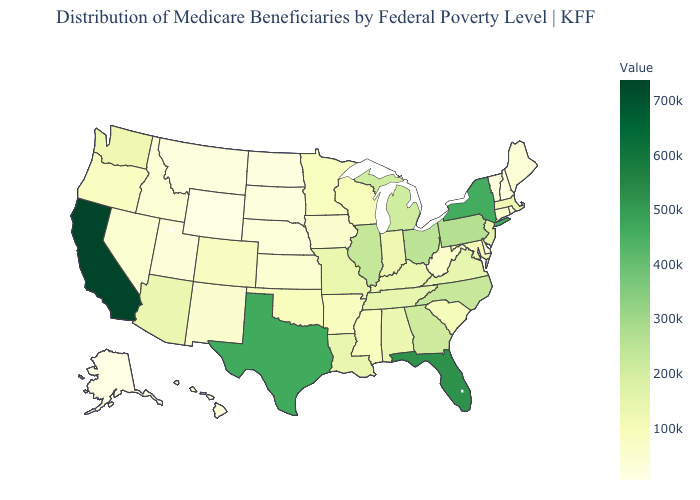Among the states that border Texas , which have the lowest value?
Keep it brief. New Mexico. Among the states that border Arizona , which have the lowest value?
Quick response, please. Utah. Does Colorado have the highest value in the West?
Write a very short answer. No. Which states hav the highest value in the MidWest?
Give a very brief answer. Ohio. Does California have the highest value in the USA?
Answer briefly. Yes. Does Alaska have the lowest value in the USA?
Short answer required. Yes. 